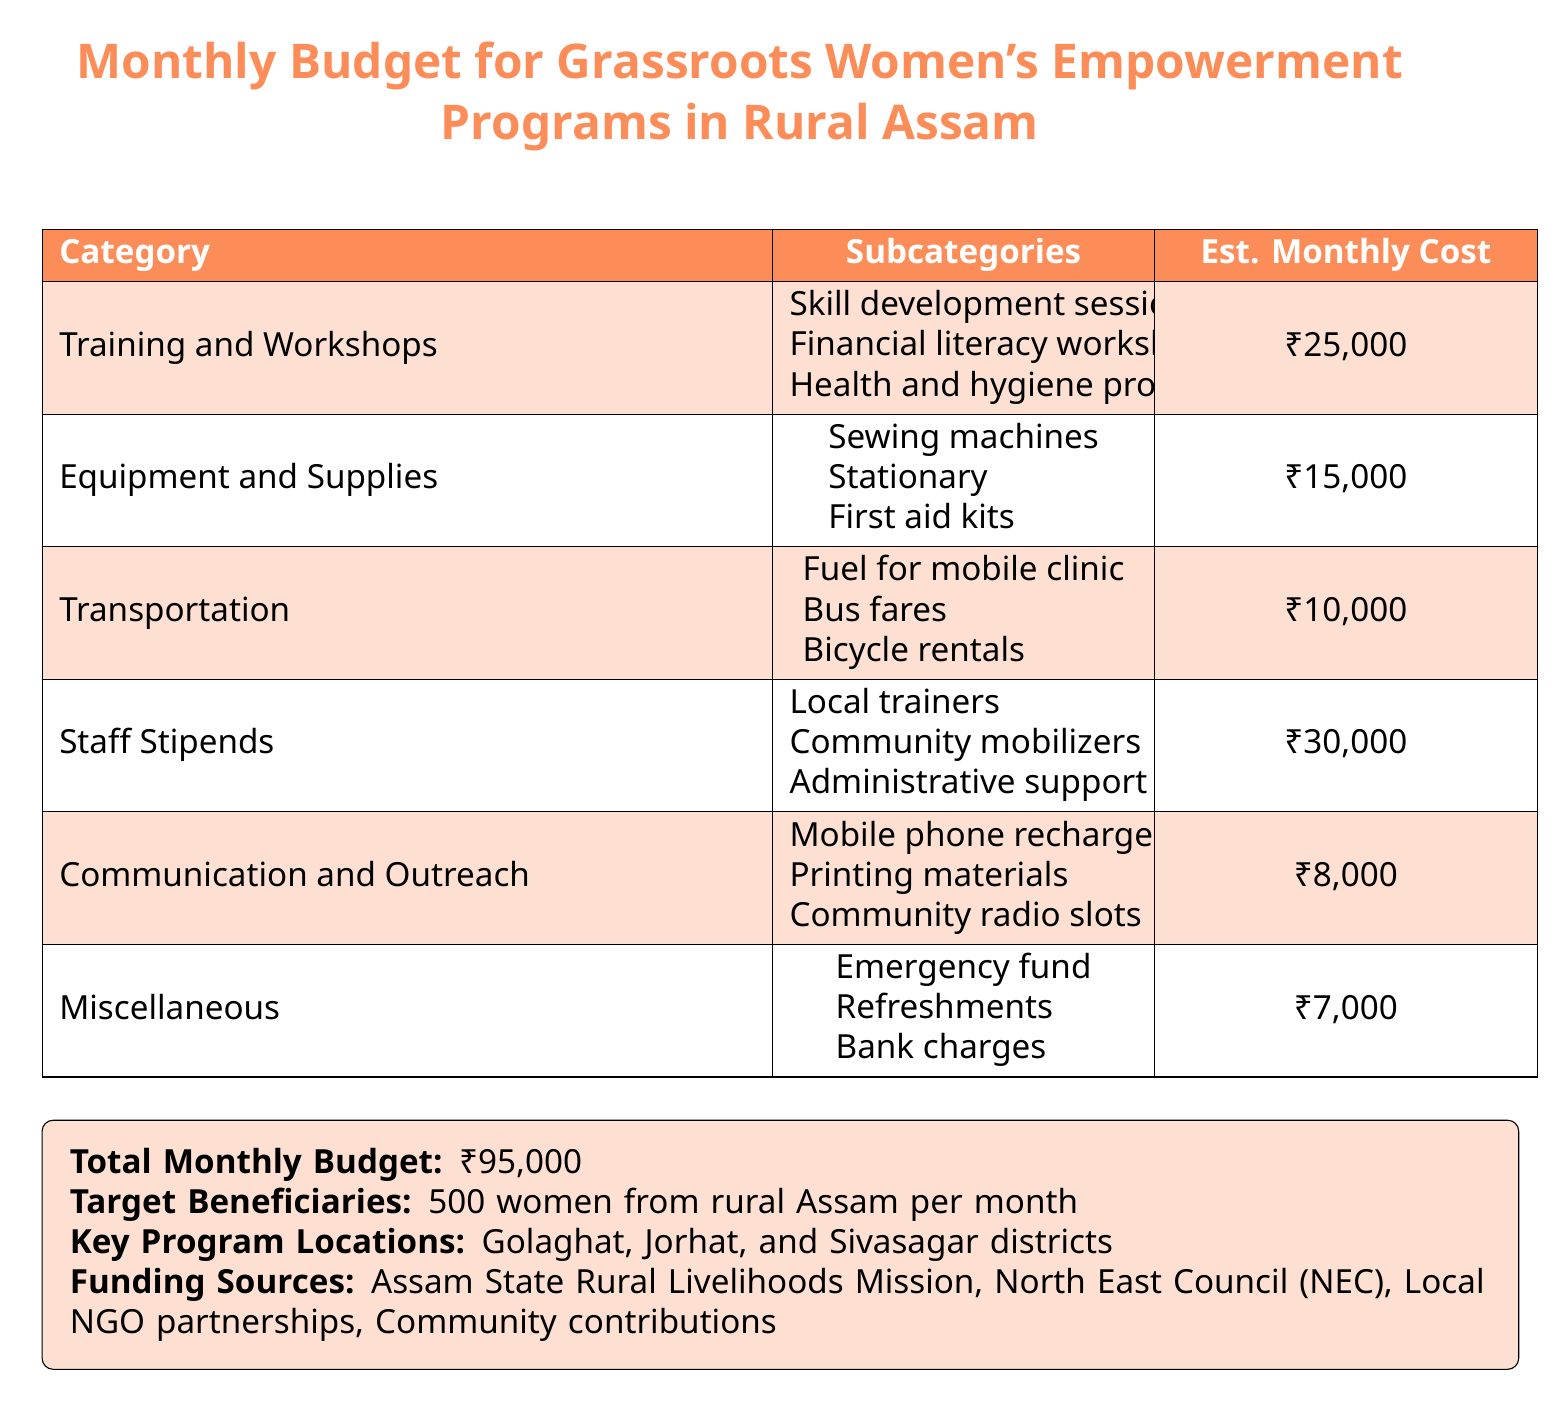What is the total monthly budget? The total monthly budget is stated at the end of the document, aggregating all expenses listed in various categories.
Answer: ₹95,000 How many beneficiaries are targeted monthly? The number of target beneficiaries is specified in a section at the end of the document, relating to outreach efforts.
Answer: 500 women What is the estimated cost for training and workshops? The estimated cost for this category is detailed in the budget table, showing the allocation for each category.
Answer: ₹25,000 Which district is mentioned as a key program location? One of the key locations is listed in the final summary part of the document, highlighting areas of focus for the program.
Answer: Golaghat What is the estimated cost for equipment and supplies? The budget table specifies the estimated costs associated with each category, including this one.
Answer: ₹15,000 What is included in the transportation costs? The document includes a list under transportation detailing what services and expenses are accounted for in this category.
Answer: Fuel for mobile clinic, Bus fares, Bicycle rentals What is the monthly staff stipends cost? The document lists the cost of staff stipends as a particular category in the budget table, specifying its total amount.
Answer: ₹30,000 What funding sources are mentioned for the program? The final summary includes a section detailing the sources of funding for the program.
Answer: Assam State Rural Livelihoods Mission, North East Council (NEC), Local NGO partnerships, Community contributions 